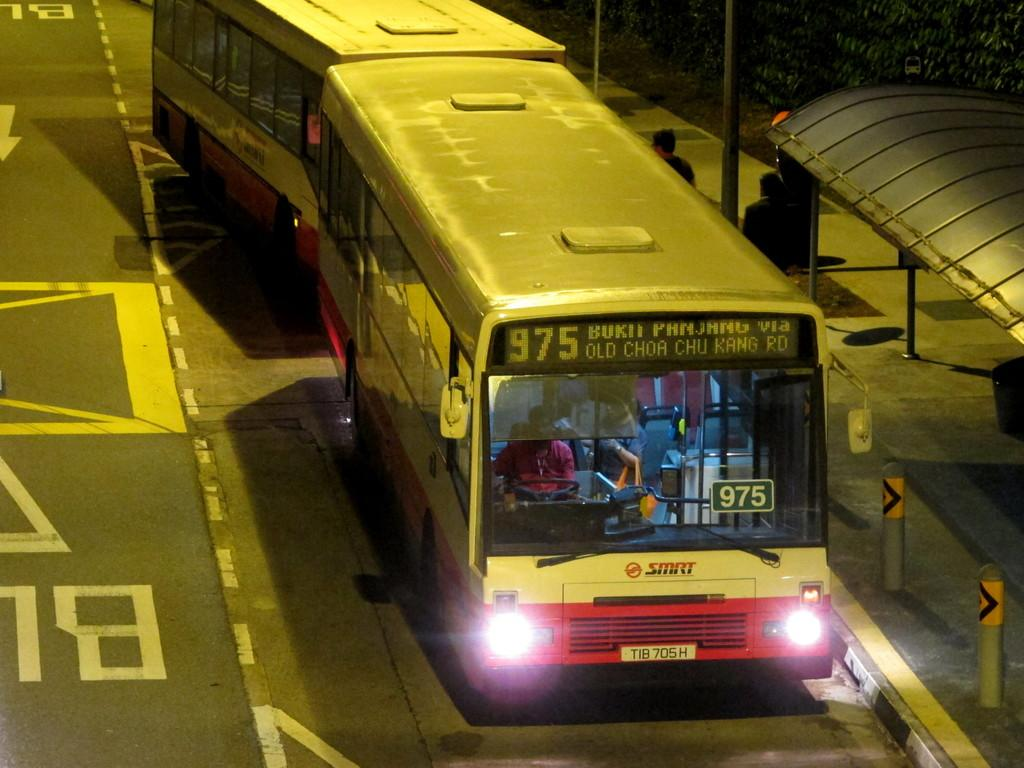What type of vehicles can be seen on the road in the image? There are two buses on the road in the image. What is the location of the scene depicted in the image? The location appears to be a bus bay. Are there any people present in the image? Yes, there are two people standing in the image. What other objects can be seen in the image? There is a pole and trees visible in the image. How many cows are grazing near the buses in the image? There are no cows present in the image; it only features buses, people, a pole, and trees. 